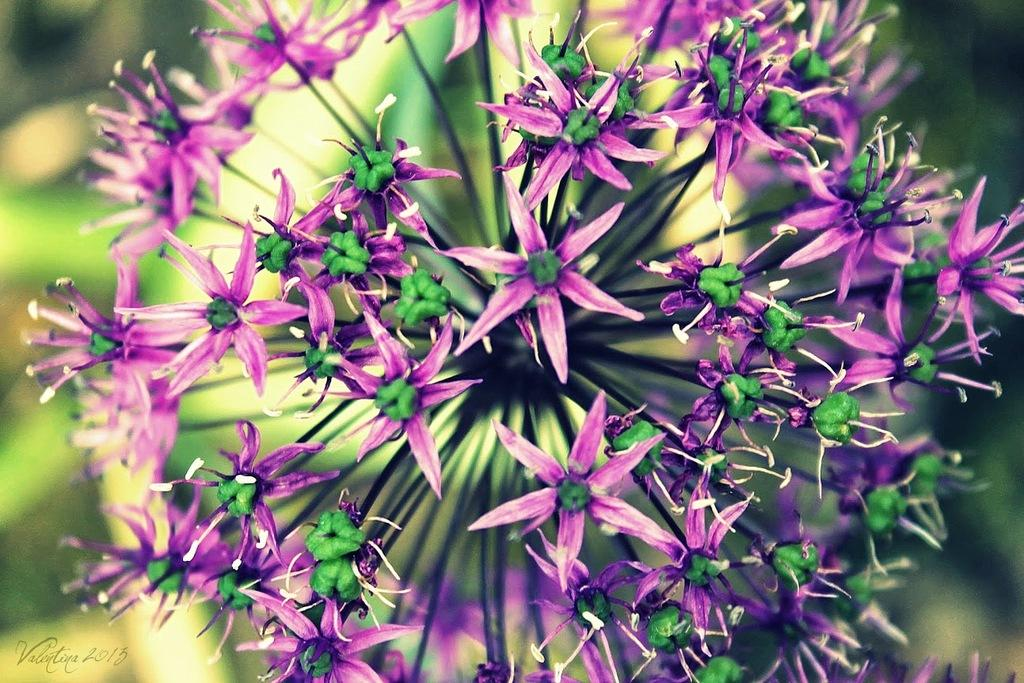What type of living organisms can be seen in the image? There are flowers on a plant in the image. Can you describe the background of the image? The background of the image is blurry. What type of airplane is the queen driving in the image? There is no airplane or queen present in the image; it features flowers on a plant with a blurry background. 